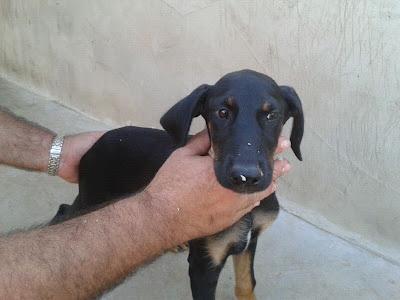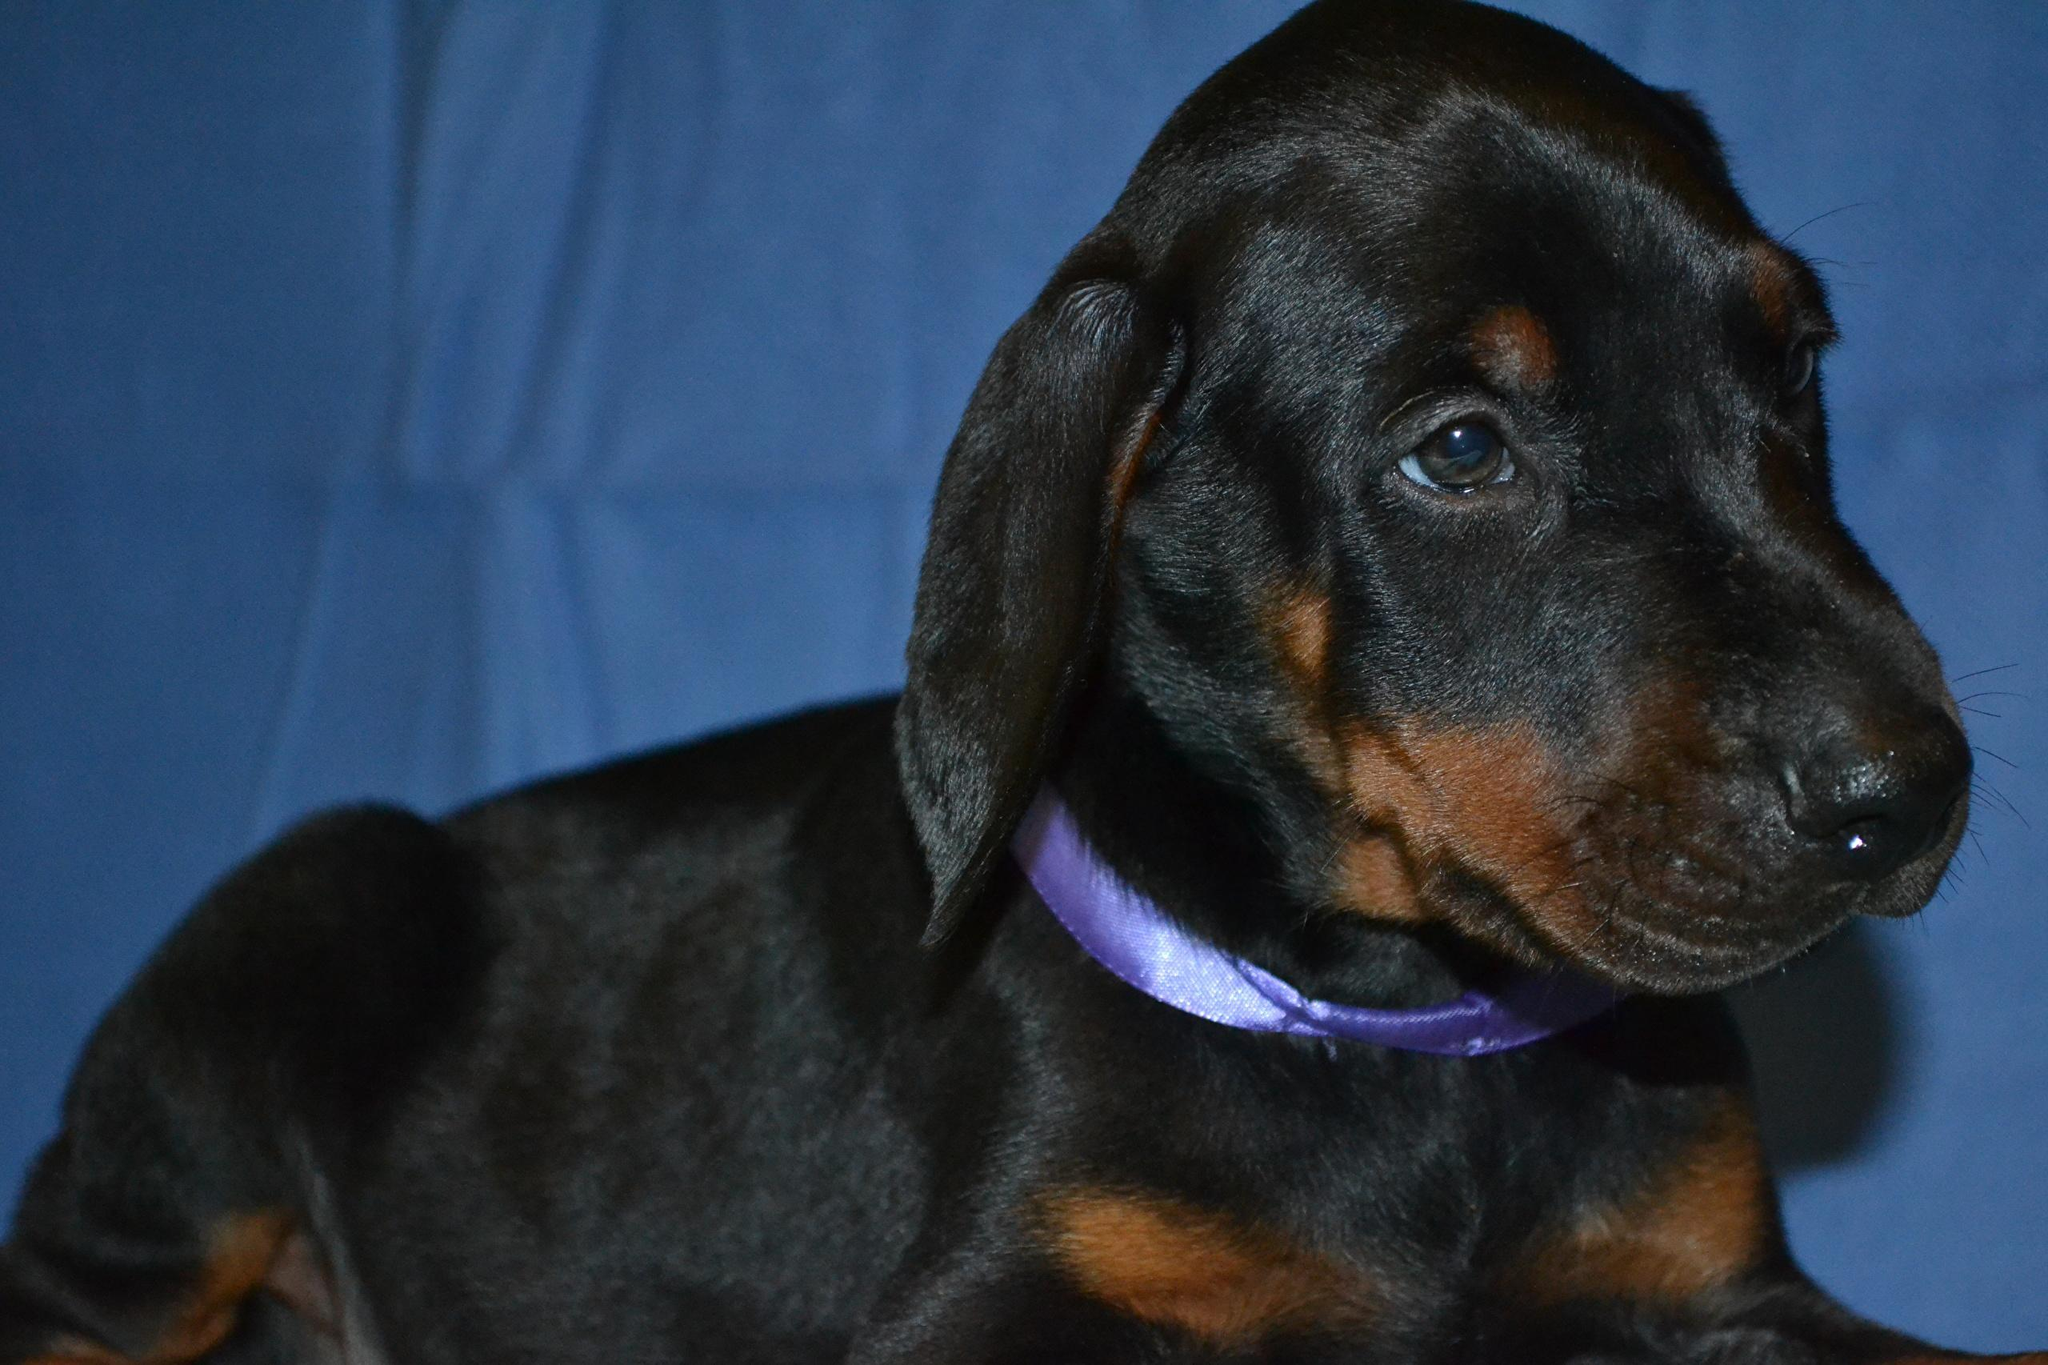The first image is the image on the left, the second image is the image on the right. Evaluate the accuracy of this statement regarding the images: "There are more dogs in the image on the right.". Is it true? Answer yes or no. No. The first image is the image on the left, the second image is the image on the right. For the images displayed, is the sentence "The left and right image contains the same number of dogs." factually correct? Answer yes or no. Yes. 